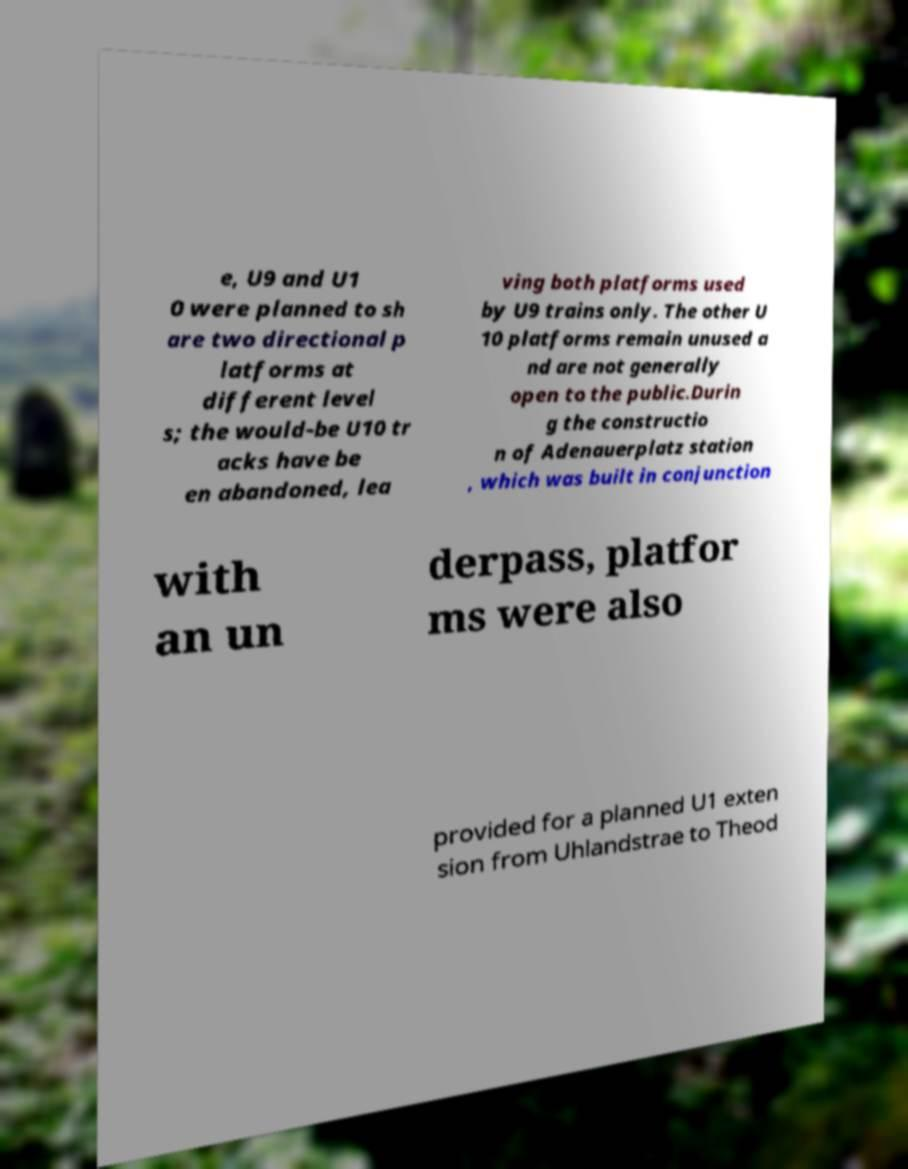Could you assist in decoding the text presented in this image and type it out clearly? e, U9 and U1 0 were planned to sh are two directional p latforms at different level s; the would-be U10 tr acks have be en abandoned, lea ving both platforms used by U9 trains only. The other U 10 platforms remain unused a nd are not generally open to the public.Durin g the constructio n of Adenauerplatz station , which was built in conjunction with an un derpass, platfor ms were also provided for a planned U1 exten sion from Uhlandstrae to Theod 